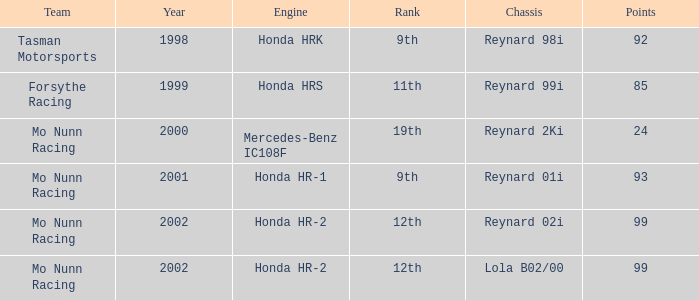What is the rank of the reynard 2ki chassis before 2002? 19th. 